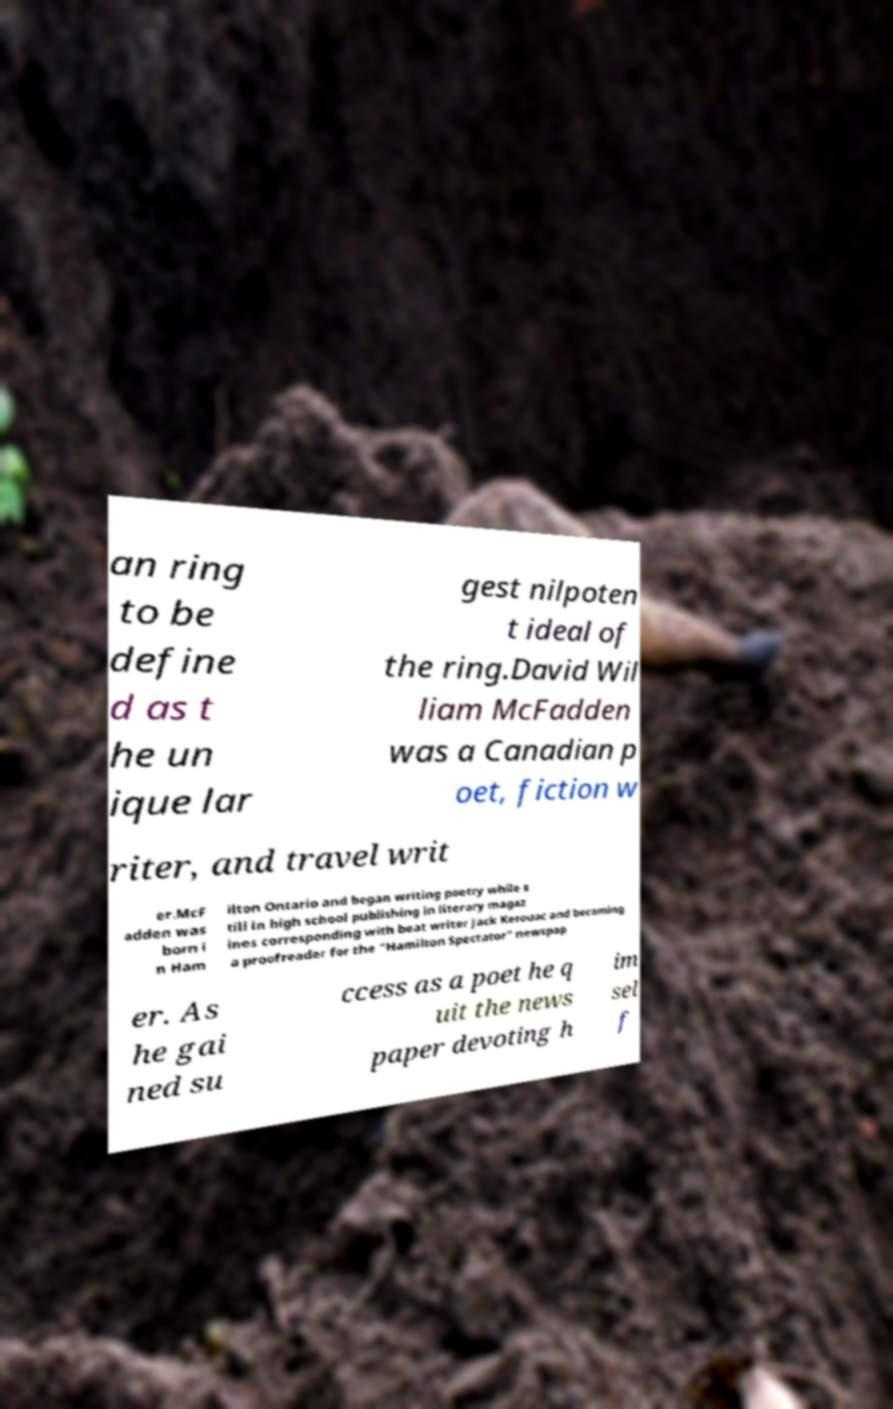Please identify and transcribe the text found in this image. an ring to be define d as t he un ique lar gest nilpoten t ideal of the ring.David Wil liam McFadden was a Canadian p oet, fiction w riter, and travel writ er.McF adden was born i n Ham ilton Ontario and began writing poetry while s till in high school publishing in literary magaz ines corresponding with beat writer Jack Kerouac and becoming a proofreader for the "Hamilton Spectator" newspap er. As he gai ned su ccess as a poet he q uit the news paper devoting h im sel f 